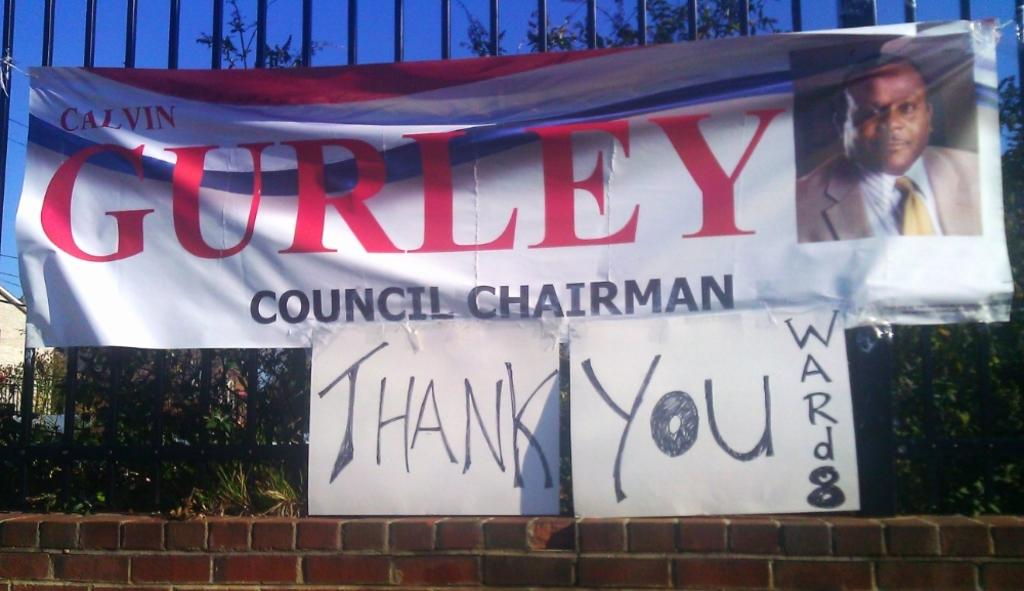What is present in the image that contains both text and an image? There is a banner in the image that contains text and an image. What can be found in the background of the image? In the background of the image, there are iron roads and trees. Can you see any dinosaurs walking on the iron roads in the background of the image? No, there are no dinosaurs present in the image. 